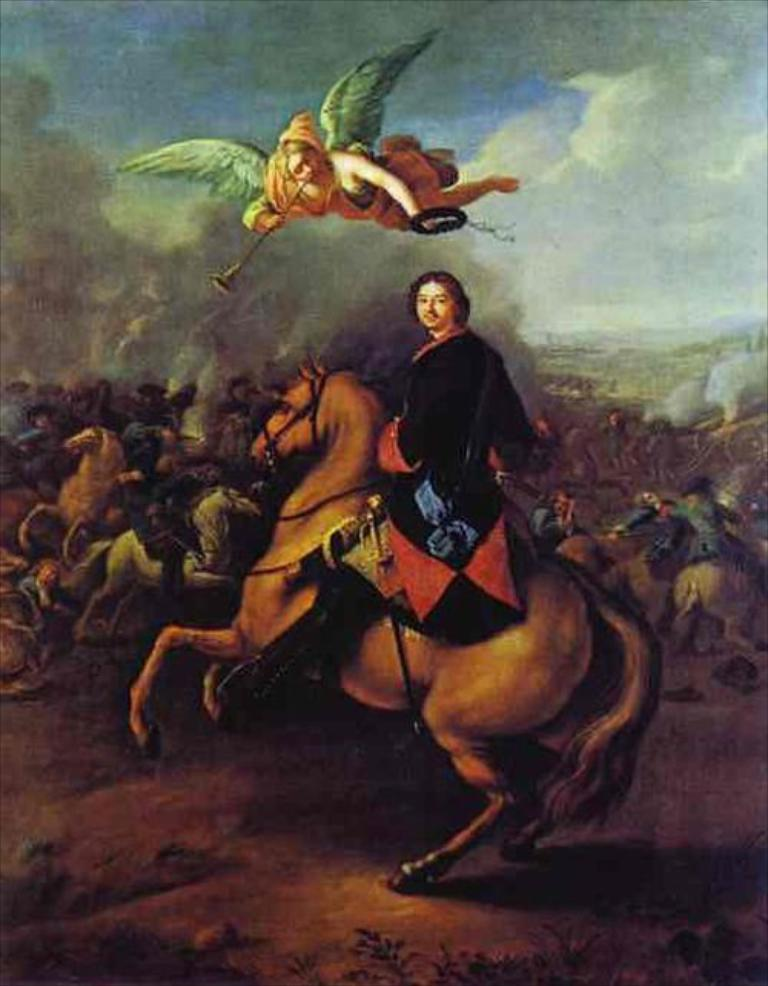What animal is featured in the image? There is a horse in the image. Who is on the horse in the image? A man is on the horse in the image. What type of artwork is the image? The image appears to be a painting. What is visible at the bottom of the image? There is ground visible at the bottom of the image. What can be seen in the sky at the top of the image? There are clouds in the sky at the top of the image. What type of plants are being used to stitch the horse's mane in the image? There are no plants or stitching present in the image; it features a horse with a man on its back in a painting. 